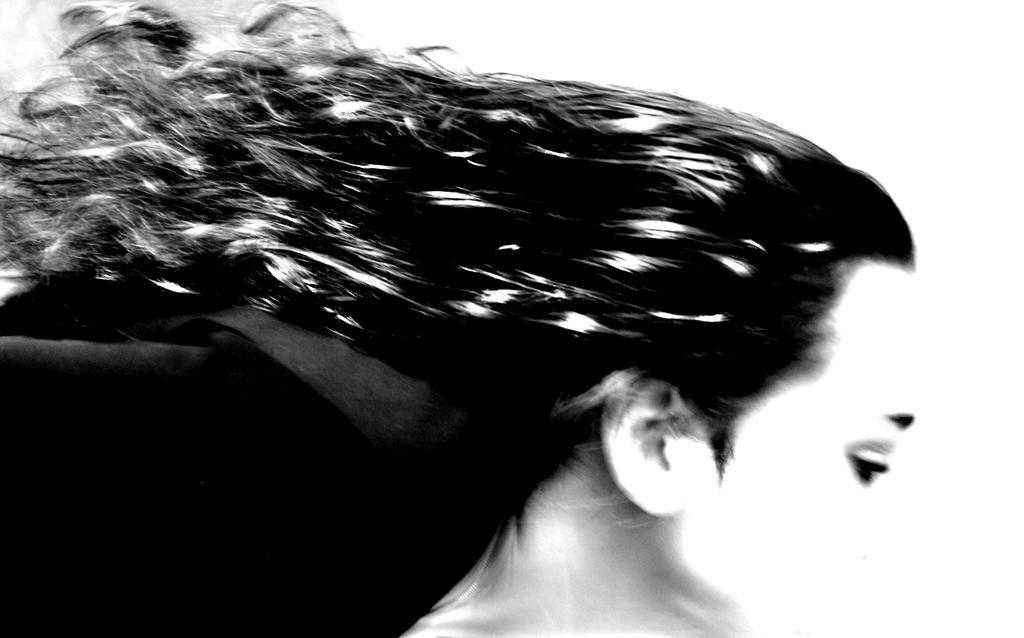Can you describe the quality of the image? The image is blurry. What type of toe pain is depicted in the image? There is no toe or pain present in the image, as it is blurry and does not show any specific details. 